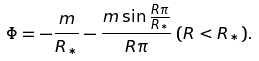Convert formula to latex. <formula><loc_0><loc_0><loc_500><loc_500>\Phi = - \frac { m } { R _ { * } } - \frac { m \sin { \frac { R \pi } { R _ { * } } } } { R \pi } \, ( R < R _ { * } ) .</formula> 